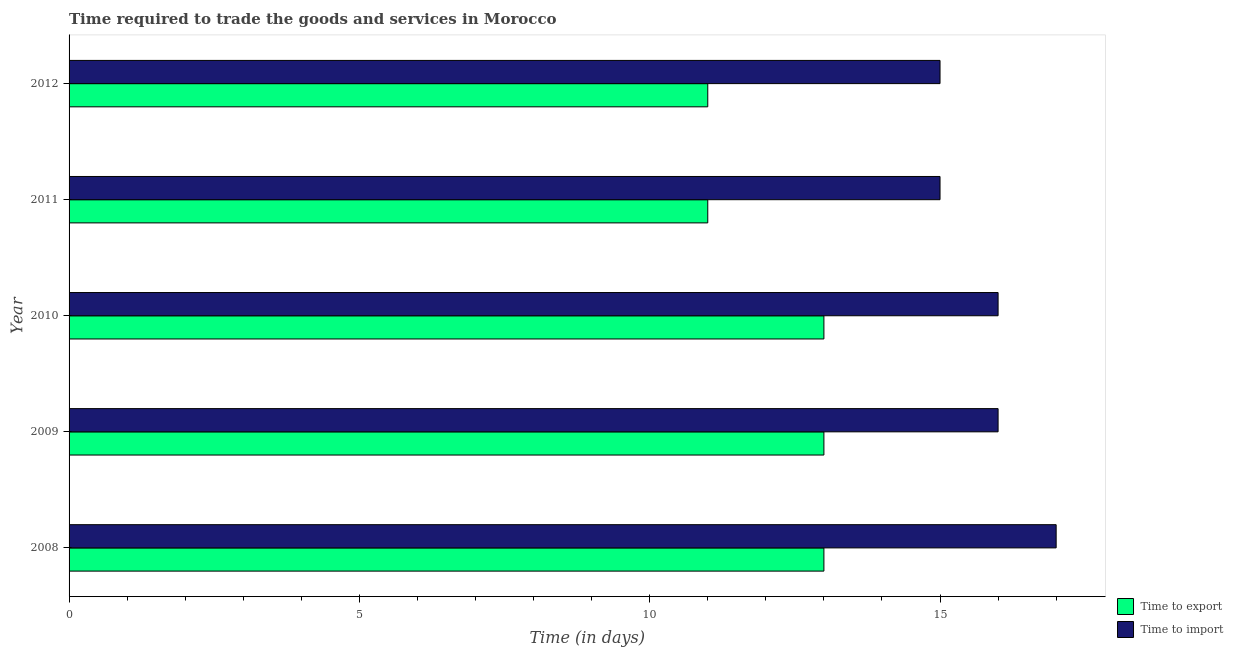How many different coloured bars are there?
Ensure brevity in your answer.  2. Are the number of bars per tick equal to the number of legend labels?
Offer a terse response. Yes. How many bars are there on the 1st tick from the top?
Your answer should be compact. 2. How many bars are there on the 1st tick from the bottom?
Ensure brevity in your answer.  2. What is the label of the 2nd group of bars from the top?
Your response must be concise. 2011. In how many cases, is the number of bars for a given year not equal to the number of legend labels?
Provide a short and direct response. 0. What is the time to export in 2012?
Offer a terse response. 11. Across all years, what is the maximum time to import?
Your answer should be very brief. 17. Across all years, what is the minimum time to export?
Provide a short and direct response. 11. In which year was the time to import maximum?
Keep it short and to the point. 2008. What is the total time to import in the graph?
Ensure brevity in your answer.  79. What is the difference between the time to export in 2009 and that in 2012?
Give a very brief answer. 2. What is the difference between the time to import in 2009 and the time to export in 2011?
Your answer should be compact. 5. What is the average time to export per year?
Your response must be concise. 12.2. In the year 2012, what is the difference between the time to export and time to import?
Your answer should be very brief. -4. In how many years, is the time to import greater than 11 days?
Make the answer very short. 5. What is the ratio of the time to import in 2009 to that in 2010?
Ensure brevity in your answer.  1. Is the difference between the time to export in 2008 and 2012 greater than the difference between the time to import in 2008 and 2012?
Ensure brevity in your answer.  No. What is the difference between the highest and the lowest time to export?
Your answer should be very brief. 2. In how many years, is the time to import greater than the average time to import taken over all years?
Give a very brief answer. 3. Is the sum of the time to export in 2008 and 2010 greater than the maximum time to import across all years?
Give a very brief answer. Yes. What does the 1st bar from the top in 2008 represents?
Give a very brief answer. Time to import. What does the 1st bar from the bottom in 2009 represents?
Keep it short and to the point. Time to export. How many bars are there?
Your answer should be compact. 10. How many years are there in the graph?
Your answer should be very brief. 5. What is the difference between two consecutive major ticks on the X-axis?
Offer a terse response. 5. Are the values on the major ticks of X-axis written in scientific E-notation?
Provide a short and direct response. No. How many legend labels are there?
Provide a short and direct response. 2. How are the legend labels stacked?
Your response must be concise. Vertical. What is the title of the graph?
Give a very brief answer. Time required to trade the goods and services in Morocco. What is the label or title of the X-axis?
Give a very brief answer. Time (in days). What is the Time (in days) of Time to export in 2008?
Your response must be concise. 13. What is the Time (in days) of Time to export in 2009?
Provide a short and direct response. 13. What is the Time (in days) in Time to export in 2010?
Keep it short and to the point. 13. What is the Time (in days) in Time to export in 2011?
Your answer should be compact. 11. What is the Time (in days) in Time to import in 2011?
Ensure brevity in your answer.  15. Across all years, what is the minimum Time (in days) of Time to export?
Offer a very short reply. 11. What is the total Time (in days) in Time to export in the graph?
Provide a short and direct response. 61. What is the total Time (in days) in Time to import in the graph?
Offer a terse response. 79. What is the difference between the Time (in days) of Time to import in 2008 and that in 2009?
Offer a terse response. 1. What is the difference between the Time (in days) in Time to export in 2008 and that in 2012?
Give a very brief answer. 2. What is the difference between the Time (in days) in Time to export in 2009 and that in 2010?
Make the answer very short. 0. What is the difference between the Time (in days) of Time to import in 2009 and that in 2010?
Offer a very short reply. 0. What is the difference between the Time (in days) in Time to import in 2009 and that in 2012?
Offer a very short reply. 1. What is the difference between the Time (in days) in Time to export in 2010 and that in 2011?
Keep it short and to the point. 2. What is the difference between the Time (in days) of Time to import in 2011 and that in 2012?
Your answer should be very brief. 0. What is the difference between the Time (in days) of Time to export in 2008 and the Time (in days) of Time to import in 2009?
Offer a very short reply. -3. What is the difference between the Time (in days) of Time to export in 2008 and the Time (in days) of Time to import in 2012?
Give a very brief answer. -2. What is the difference between the Time (in days) of Time to export in 2010 and the Time (in days) of Time to import in 2012?
Make the answer very short. -2. What is the difference between the Time (in days) of Time to export in 2011 and the Time (in days) of Time to import in 2012?
Provide a short and direct response. -4. In the year 2008, what is the difference between the Time (in days) in Time to export and Time (in days) in Time to import?
Offer a very short reply. -4. In the year 2009, what is the difference between the Time (in days) of Time to export and Time (in days) of Time to import?
Keep it short and to the point. -3. In the year 2011, what is the difference between the Time (in days) in Time to export and Time (in days) in Time to import?
Keep it short and to the point. -4. What is the ratio of the Time (in days) in Time to export in 2008 to that in 2009?
Your answer should be very brief. 1. What is the ratio of the Time (in days) in Time to import in 2008 to that in 2009?
Offer a terse response. 1.06. What is the ratio of the Time (in days) of Time to export in 2008 to that in 2011?
Make the answer very short. 1.18. What is the ratio of the Time (in days) of Time to import in 2008 to that in 2011?
Your answer should be very brief. 1.13. What is the ratio of the Time (in days) of Time to export in 2008 to that in 2012?
Your response must be concise. 1.18. What is the ratio of the Time (in days) of Time to import in 2008 to that in 2012?
Ensure brevity in your answer.  1.13. What is the ratio of the Time (in days) of Time to import in 2009 to that in 2010?
Ensure brevity in your answer.  1. What is the ratio of the Time (in days) in Time to export in 2009 to that in 2011?
Make the answer very short. 1.18. What is the ratio of the Time (in days) of Time to import in 2009 to that in 2011?
Ensure brevity in your answer.  1.07. What is the ratio of the Time (in days) in Time to export in 2009 to that in 2012?
Your answer should be very brief. 1.18. What is the ratio of the Time (in days) of Time to import in 2009 to that in 2012?
Keep it short and to the point. 1.07. What is the ratio of the Time (in days) in Time to export in 2010 to that in 2011?
Give a very brief answer. 1.18. What is the ratio of the Time (in days) in Time to import in 2010 to that in 2011?
Offer a very short reply. 1.07. What is the ratio of the Time (in days) of Time to export in 2010 to that in 2012?
Make the answer very short. 1.18. What is the ratio of the Time (in days) in Time to import in 2010 to that in 2012?
Your answer should be compact. 1.07. What is the difference between the highest and the lowest Time (in days) in Time to import?
Your answer should be compact. 2. 